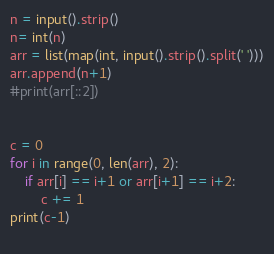Convert code to text. <code><loc_0><loc_0><loc_500><loc_500><_Python_>n = input().strip()
n= int(n)
arr = list(map(int, input().strip().split(' ')))
arr.append(n+1)
#print(arr[::2])


c = 0
for i in range(0, len(arr), 2):
    if arr[i] == i+1 or arr[i+1] == i+2:
        c += 1
print(c-1)
        </code> 